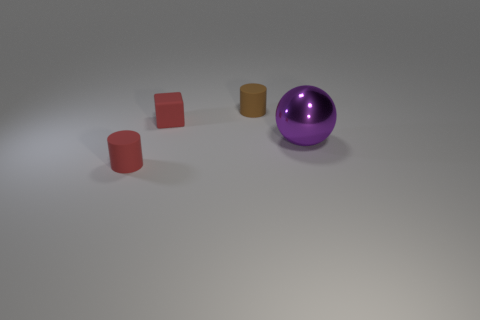Add 4 tiny objects. How many objects exist? 8 Subtract 1 spheres. How many spheres are left? 0 Add 4 red matte cubes. How many red matte cubes are left? 5 Add 4 small balls. How many small balls exist? 4 Subtract 0 green cylinders. How many objects are left? 4 Subtract all blue balls. Subtract all brown cylinders. How many balls are left? 1 Subtract all green blocks. How many brown cylinders are left? 1 Subtract all red matte cubes. Subtract all tiny red things. How many objects are left? 1 